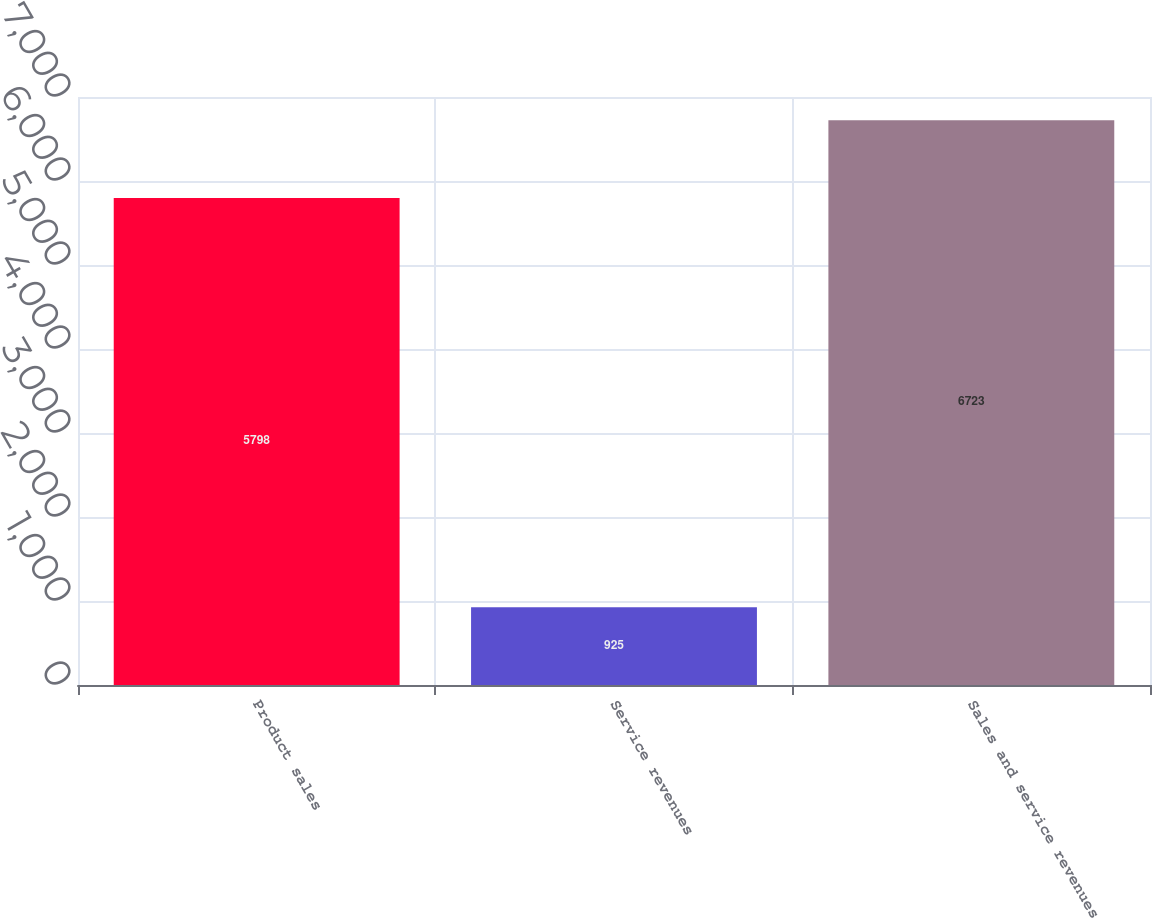<chart> <loc_0><loc_0><loc_500><loc_500><bar_chart><fcel>Product sales<fcel>Service revenues<fcel>Sales and service revenues<nl><fcel>5798<fcel>925<fcel>6723<nl></chart> 